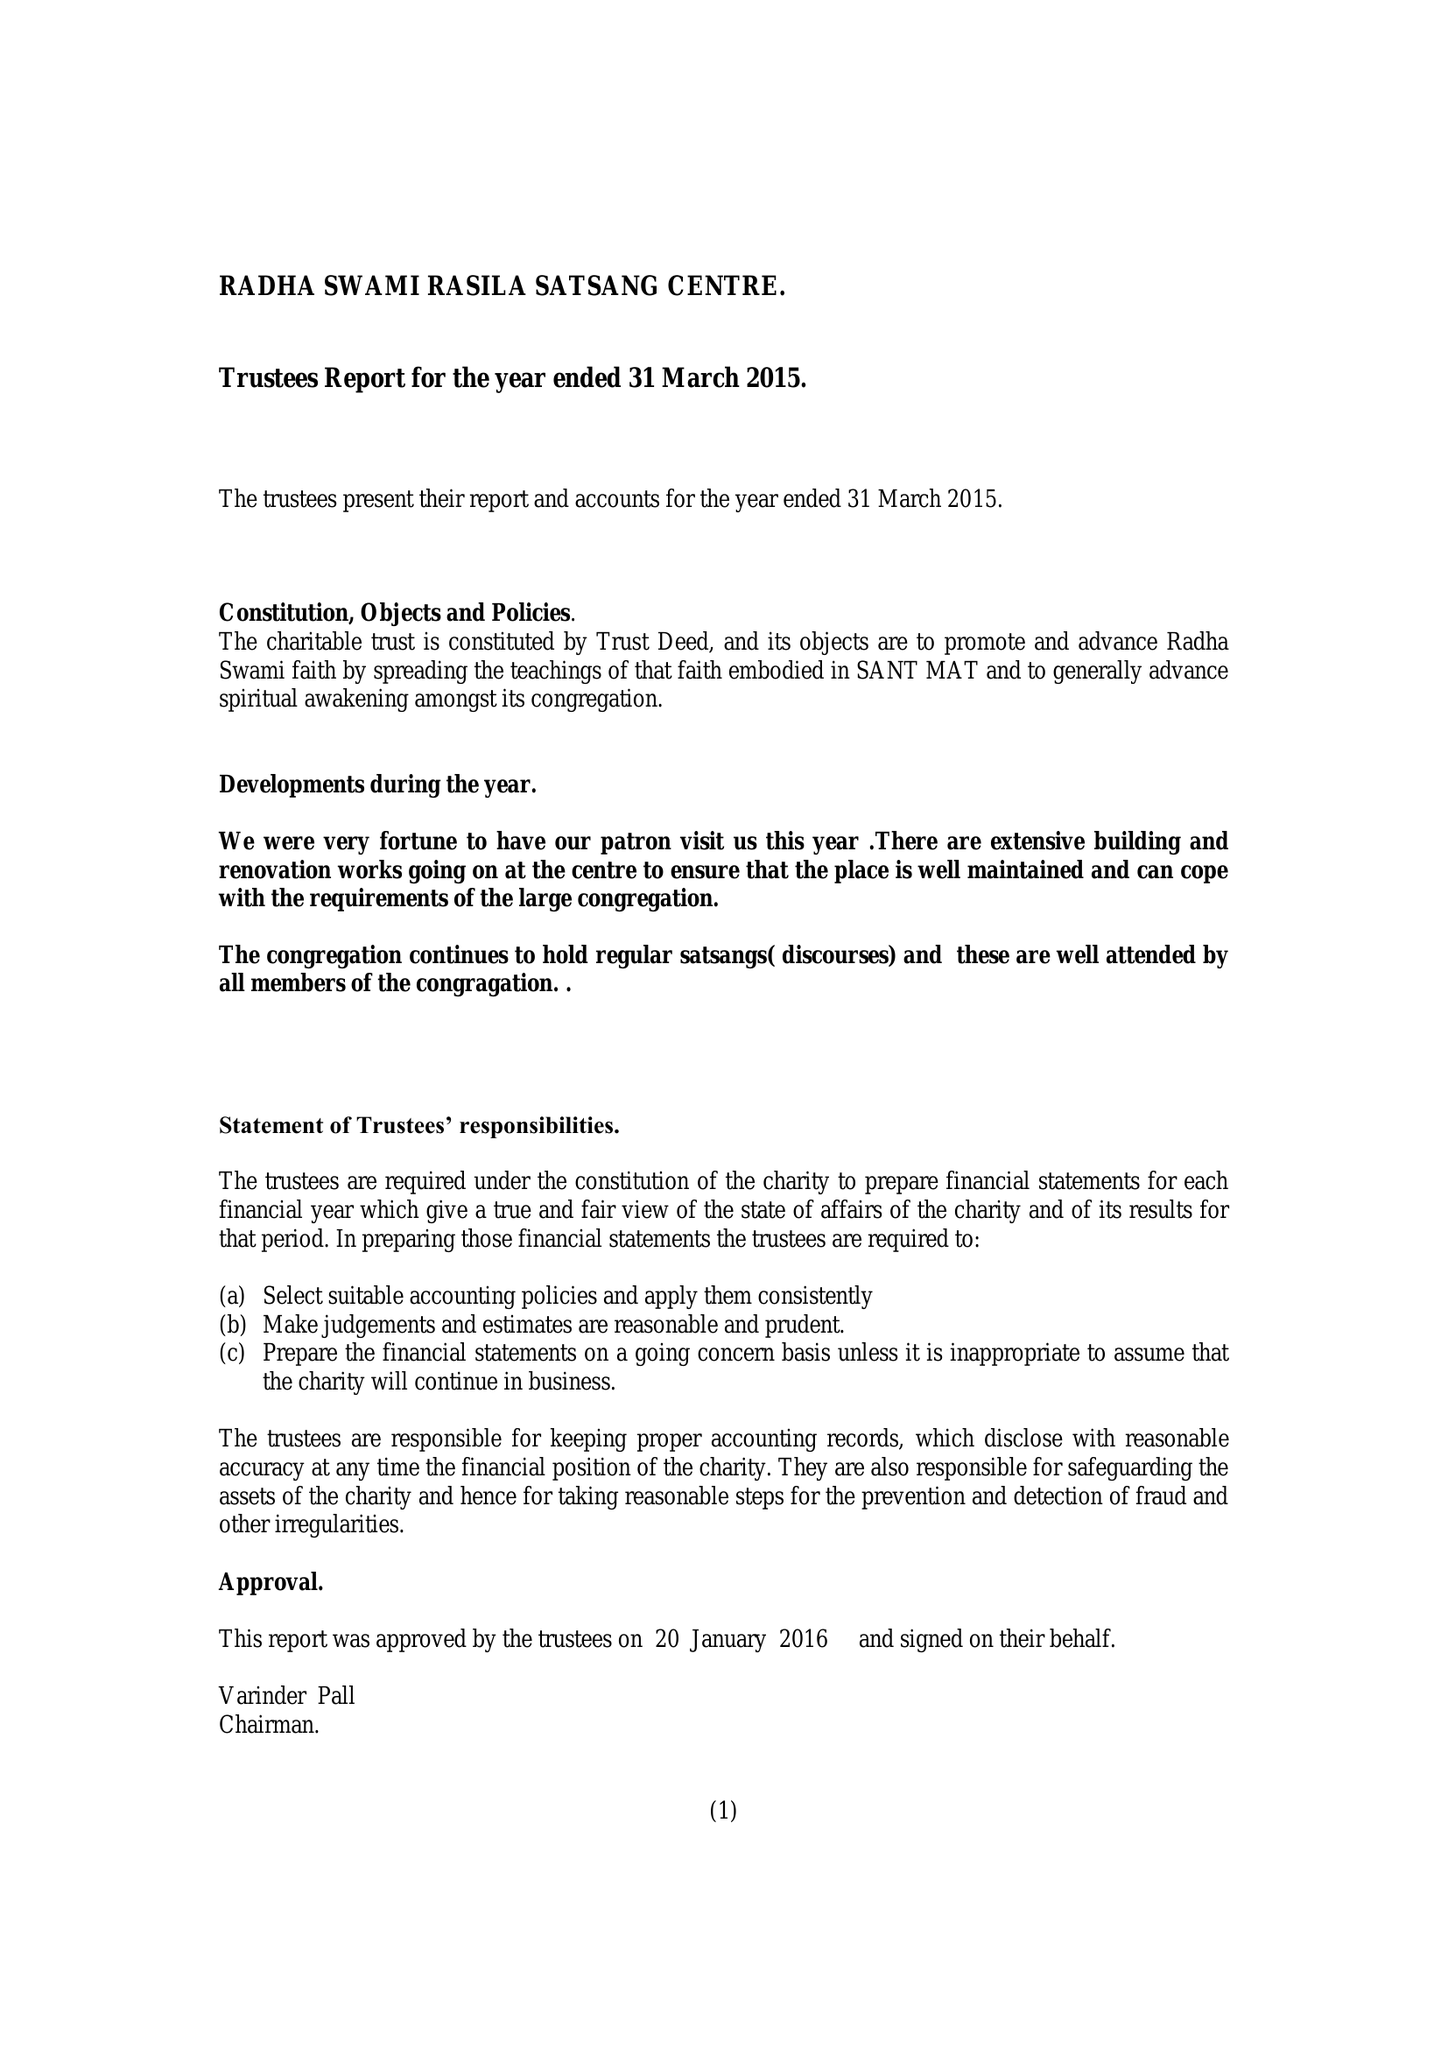What is the value for the spending_annually_in_british_pounds?
Answer the question using a single word or phrase. 52450.00 